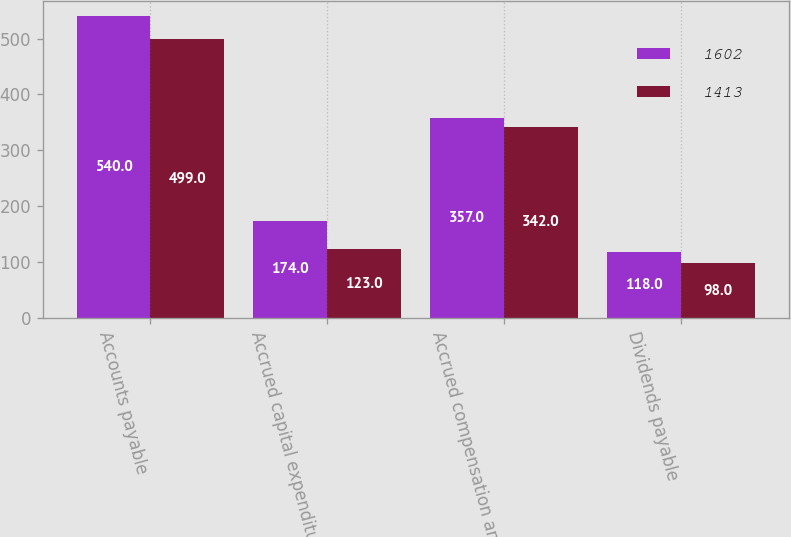<chart> <loc_0><loc_0><loc_500><loc_500><stacked_bar_chart><ecel><fcel>Accounts payable<fcel>Accrued capital expenditures<fcel>Accrued compensation and<fcel>Dividends payable<nl><fcel>1602<fcel>540<fcel>174<fcel>357<fcel>118<nl><fcel>1413<fcel>499<fcel>123<fcel>342<fcel>98<nl></chart> 